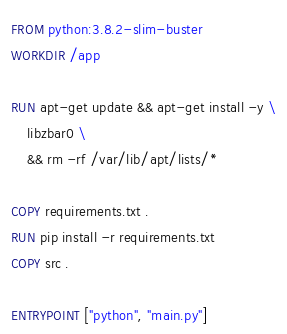Convert code to text. <code><loc_0><loc_0><loc_500><loc_500><_Dockerfile_>FROM python:3.8.2-slim-buster
WORKDIR /app

RUN apt-get update && apt-get install -y \
    libzbar0 \
    && rm -rf /var/lib/apt/lists/*

COPY requirements.txt .
RUN pip install -r requirements.txt
COPY src .

ENTRYPOINT ["python", "main.py"]
</code> 